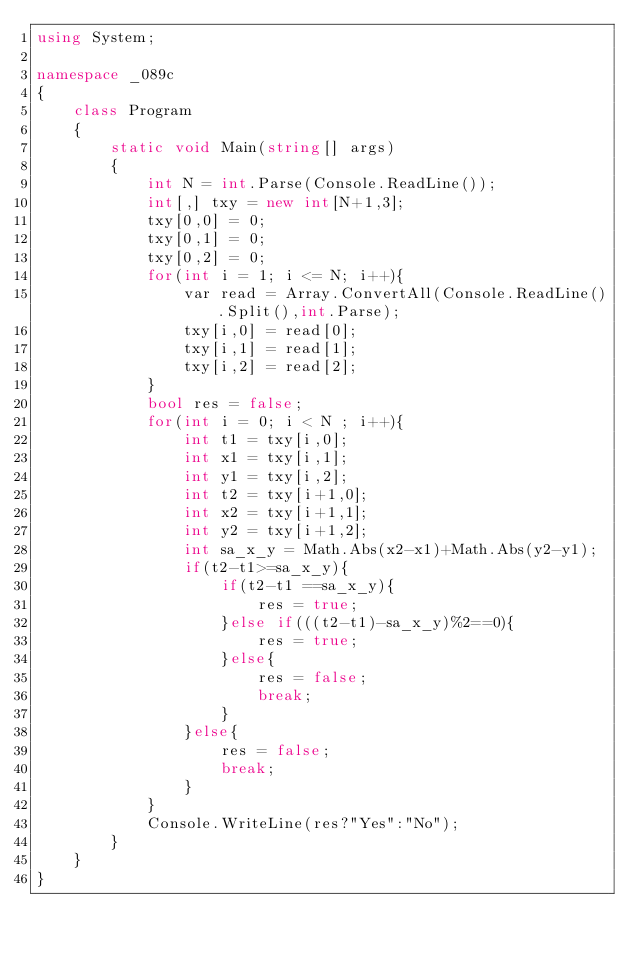Convert code to text. <code><loc_0><loc_0><loc_500><loc_500><_C#_>using System;

namespace _089c
{
    class Program
    {
        static void Main(string[] args)
        {
            int N = int.Parse(Console.ReadLine());
            int[,] txy = new int[N+1,3];
            txy[0,0] = 0;
            txy[0,1] = 0;
            txy[0,2] = 0;
            for(int i = 1; i <= N; i++){
                var read = Array.ConvertAll(Console.ReadLine().Split(),int.Parse);
                txy[i,0] = read[0];
                txy[i,1] = read[1];
                txy[i,2] = read[2];
            } 
            bool res = false;
            for(int i = 0; i < N ; i++){
                int t1 = txy[i,0];
                int x1 = txy[i,1];
                int y1 = txy[i,2];  
                int t2 = txy[i+1,0];
                int x2 = txy[i+1,1];
                int y2 = txy[i+1,2];
                int sa_x_y = Math.Abs(x2-x1)+Math.Abs(y2-y1);
                if(t2-t1>=sa_x_y){
                    if(t2-t1 ==sa_x_y){
                        res = true;
                    }else if(((t2-t1)-sa_x_y)%2==0){
                        res = true;
                    }else{
                        res = false;
                        break;
                    }
                }else{
                    res = false;
                    break;
                }  
            }
            Console.WriteLine(res?"Yes":"No");
        }
    }
}</code> 